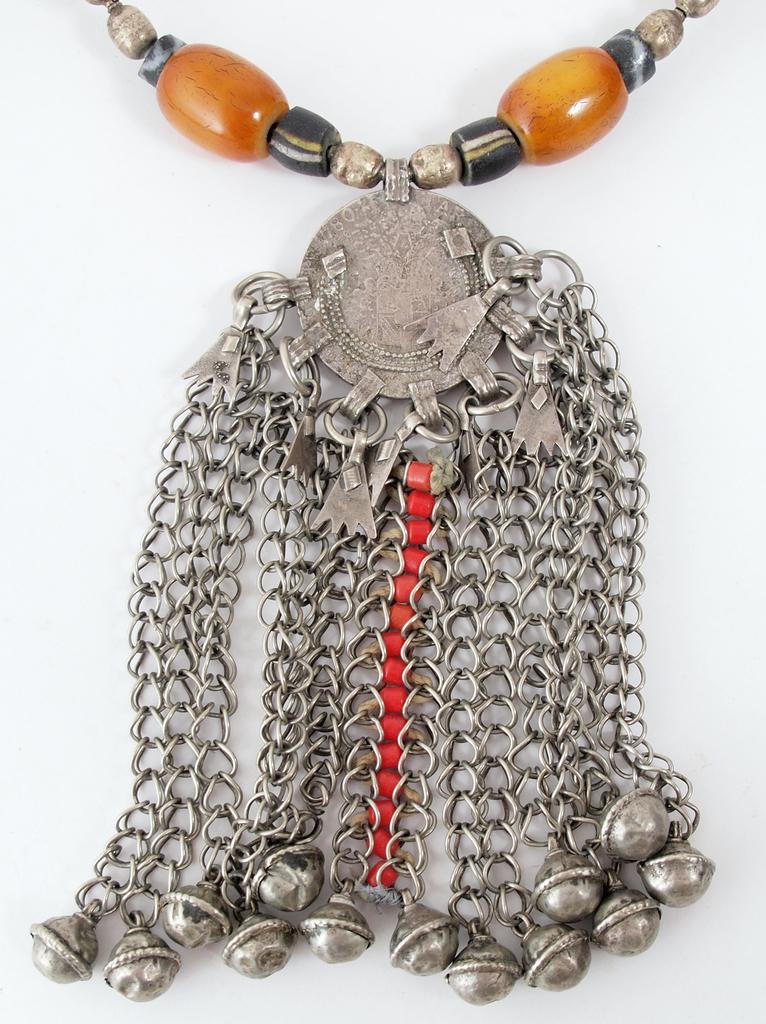What type of item is featured in the image? There is jewelry in the image. What is the color of the surface on which the jewelry is placed? The jewelry is placed on a white surface. What type of glove is shown holding the cheese in the image? There is no glove or cheese present in the image; it only features jewelry on a white surface. 